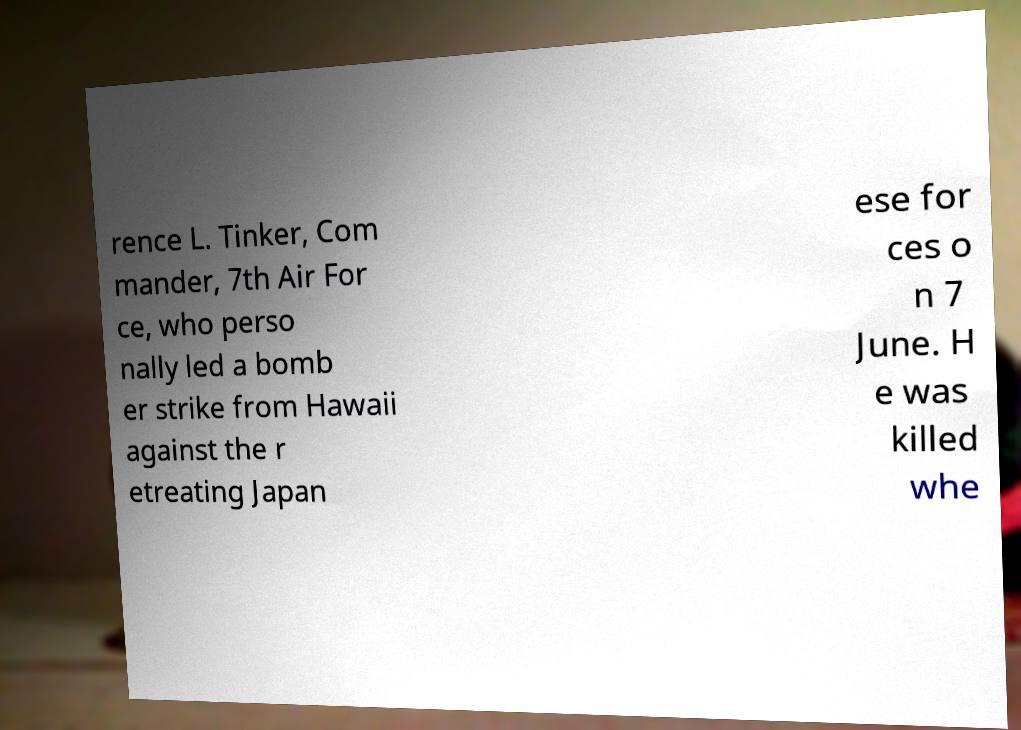For documentation purposes, I need the text within this image transcribed. Could you provide that? rence L. Tinker, Com mander, 7th Air For ce, who perso nally led a bomb er strike from Hawaii against the r etreating Japan ese for ces o n 7 June. H e was killed whe 